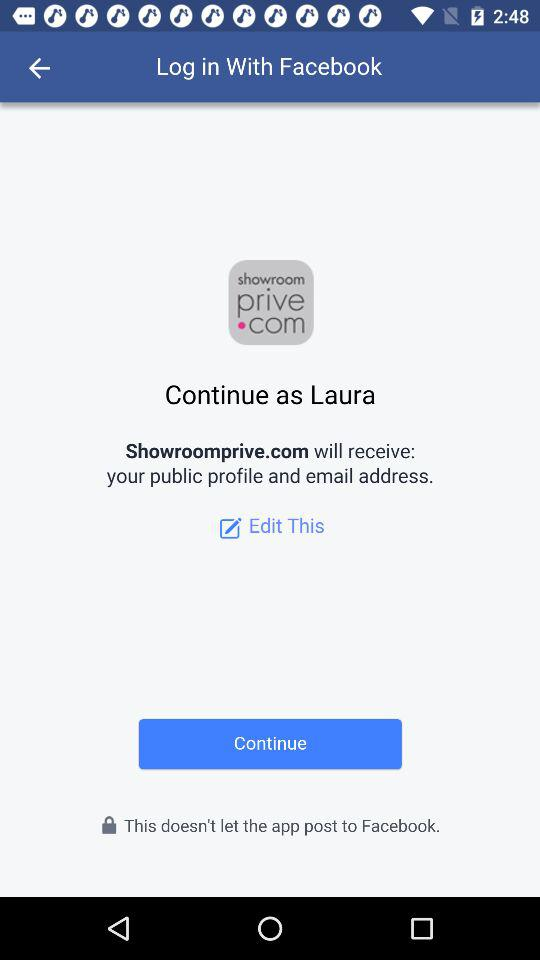What application is asking for permission? The application asking for permission is "Showroomprive.com". 